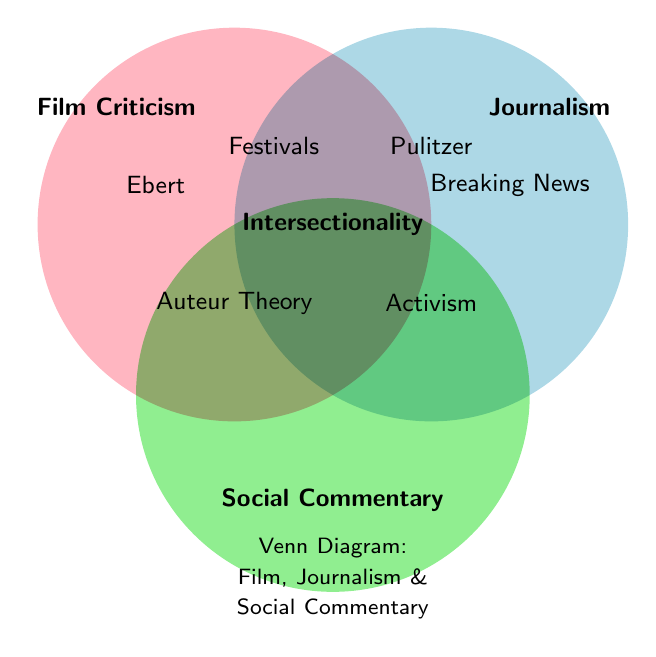What are the three major themes represented in the Venn Diagram? The Venn Diagram includes three major themes labeled as Film Criticism, Journalism, and Social Commentary.
Answer: Film Criticism, Journalism, Social Commentary Which key concept is shared by all three themes in the Venn Diagram? The shared key concept is located at the intersection of all three circles in the Venn Diagram. It is labeled "Intersectionality."
Answer: Intersectionality What elements are uniquely associated with Film Criticism according to the Venn Diagram? The elements uniquely associated with Film Criticism are those located only within the Film Criticism circle and not overlapping with others. These elements are "Ebert" and "Festivals".
Answer: Ebert, Festivals Identify an element that is common between Journalism and Social Commentary. To find this element, look for the region where the Journalism and Social Commentary circles overlap. The element located here is "Activism."
Answer: Activism Compare the representation of individual contributors/organizations in the Film Criticism section with that in the Journalism section. How many are there in each? Film Criticism has "Ebert" while Journalism has "Breaking News" and "Pulitzer." So Film Criticism has 1 element, and Journalism has 2 elements.
Answer: Film Criticism: 1, Journalism: 2 Which element in the Venn Diagram is solely associated with Journalism but not with the other two themes? The element solely associated with Journalism is found within its circle without overlap. This is "Breaking News."
Answer: Breaking News Explain the placement of the element "Auteur Theory" in the Venn Diagram. "Auteur Theory" is in the shared region of Film Criticism and Social Commentary, indicating it intersects both themes but not Journalism.
Answer: Film Criticism & Social Commentary If a new element "Cultural Critique" were to be added and it intersects with Film Criticism, Journalism, and Social Commentary, where would it be placed in the Venn Diagram? It would be placed alongside "Intersectionality" in the center where all three circles overlap, representing all three themes.
Answer: Center intersection What logical operation determines the placement of "Pulitzer" in the Venn Diagram? "Pulitzer" is placed in the overlapping region of Film Criticism and Journalism, indicating it is related to both but not Social Commentary. The logical operation here is the intersection of two sets.
Answer: Overlap of Film Criticism and Journalism 